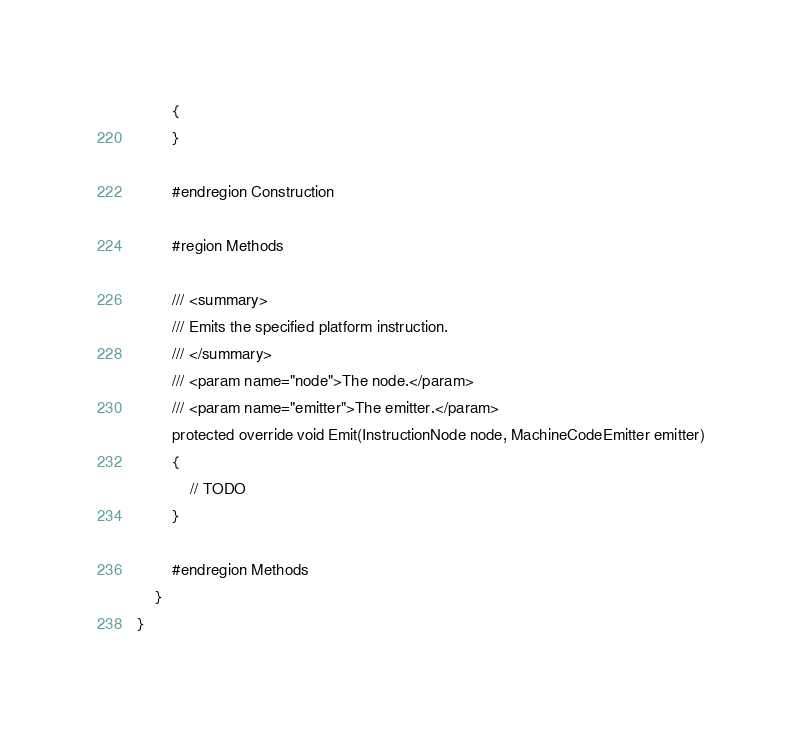Convert code to text. <code><loc_0><loc_0><loc_500><loc_500><_C#_>		{
		}

		#endregion Construction

		#region Methods

		/// <summary>
		/// Emits the specified platform instruction.
		/// </summary>
		/// <param name="node">The node.</param>
		/// <param name="emitter">The emitter.</param>
		protected override void Emit(InstructionNode node, MachineCodeEmitter emitter)
		{
			// TODO
		}

		#endregion Methods
	}
}
</code> 